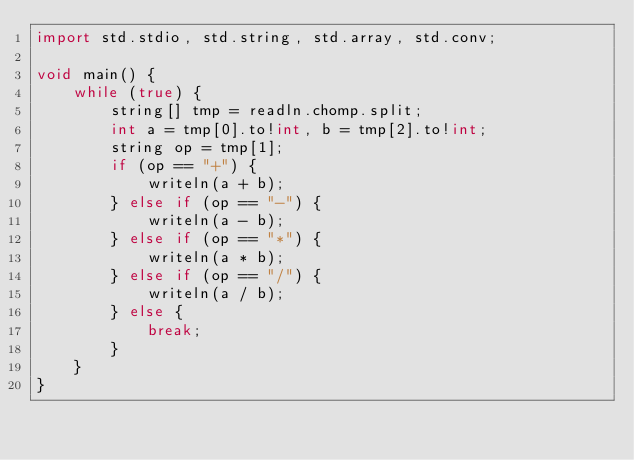<code> <loc_0><loc_0><loc_500><loc_500><_D_>import std.stdio, std.string, std.array, std.conv;

void main() {
    while (true) {
        string[] tmp = readln.chomp.split;
        int a = tmp[0].to!int, b = tmp[2].to!int;
        string op = tmp[1];
        if (op == "+") {
            writeln(a + b);
        } else if (op == "-") {
            writeln(a - b);
        } else if (op == "*") {
            writeln(a * b);
        } else if (op == "/") {
            writeln(a / b);
        } else {
            break;
        }
    }
}
</code> 